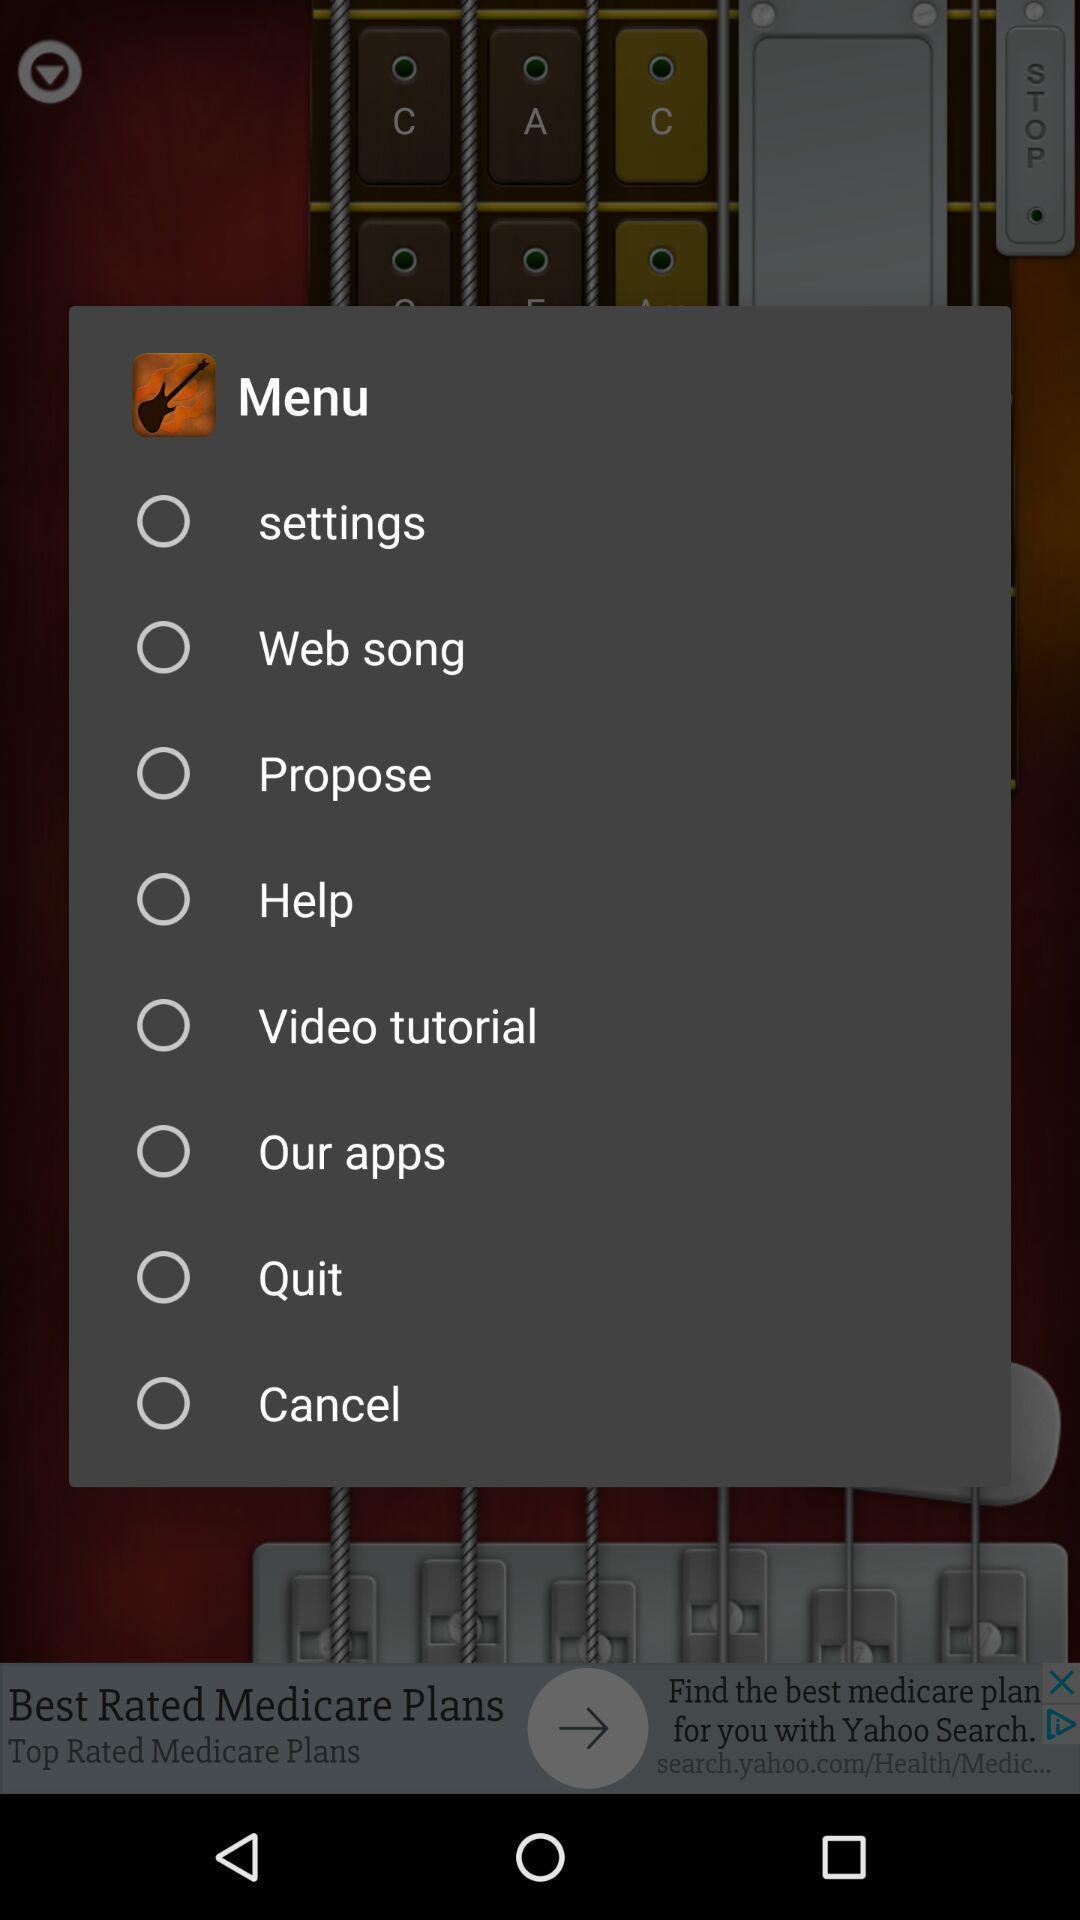Describe this image in words. Screen displaying the menu. 